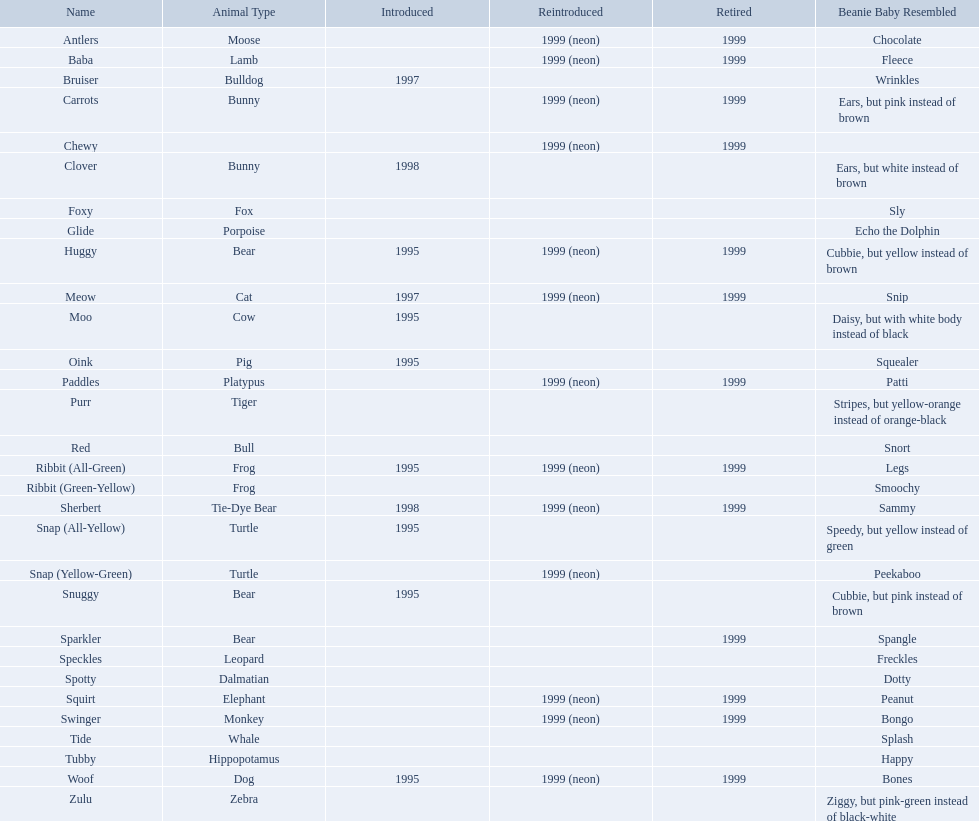What are all the different names of the pillow pals? Antlers, Baba, Bruiser, Carrots, Chewy, Clover, Foxy, Glide, Huggy, Meow, Moo, Oink, Paddles, Purr, Red, Ribbit (All-Green), Ribbit (Green-Yellow), Sherbert, Snap (All-Yellow), Snap (Yellow-Green), Snuggy, Sparkler, Speckles, Spotty, Squirt, Swinger, Tide, Tubby, Woof, Zulu. Which of these are a dalmatian? Spotty. What are the names listed? Antlers, Baba, Bruiser, Carrots, Chewy, Clover, Foxy, Glide, Huggy, Meow, Moo, Oink, Paddles, Purr, Red, Ribbit (All-Green), Ribbit (Green-Yellow), Sherbert, Snap (All-Yellow), Snap (Yellow-Green), Snuggy, Sparkler, Speckles, Spotty, Squirt, Swinger, Tide, Tubby, Woof, Zulu. Of these, which is the only pet without an animal type listed? Chewy. What are all the pillow pals? Antlers, Baba, Bruiser, Carrots, Chewy, Clover, Foxy, Glide, Huggy, Meow, Moo, Oink, Paddles, Purr, Red, Ribbit (All-Green), Ribbit (Green-Yellow), Sherbert, Snap (All-Yellow), Snap (Yellow-Green), Snuggy, Sparkler, Speckles, Spotty, Squirt, Swinger, Tide, Tubby, Woof, Zulu. Which is the only without a listed animal type? Chewy. What are the outlined names? Antlers, Baba, Bruiser, Carrots, Chewy, Clover, Foxy, Glide, Huggy, Meow, Moo, Oink, Paddles, Purr, Red, Ribbit (All-Green), Ribbit (Green-Yellow), Sherbert, Snap (All-Yellow), Snap (Yellow-Green), Snuggy, Sparkler, Speckles, Spotty, Squirt, Swinger, Tide, Tubby, Woof, Zulu. Could you parse the entire table as a dict? {'header': ['Name', 'Animal Type', 'Introduced', 'Reintroduced', 'Retired', 'Beanie Baby Resembled'], 'rows': [['Antlers', 'Moose', '', '1999 (neon)', '1999', 'Chocolate'], ['Baba', 'Lamb', '', '1999 (neon)', '1999', 'Fleece'], ['Bruiser', 'Bulldog', '1997', '', '', 'Wrinkles'], ['Carrots', 'Bunny', '', '1999 (neon)', '1999', 'Ears, but pink instead of brown'], ['Chewy', '', '', '1999 (neon)', '1999', ''], ['Clover', 'Bunny', '1998', '', '', 'Ears, but white instead of brown'], ['Foxy', 'Fox', '', '', '', 'Sly'], ['Glide', 'Porpoise', '', '', '', 'Echo the Dolphin'], ['Huggy', 'Bear', '1995', '1999 (neon)', '1999', 'Cubbie, but yellow instead of brown'], ['Meow', 'Cat', '1997', '1999 (neon)', '1999', 'Snip'], ['Moo', 'Cow', '1995', '', '', 'Daisy, but with white body instead of black'], ['Oink', 'Pig', '1995', '', '', 'Squealer'], ['Paddles', 'Platypus', '', '1999 (neon)', '1999', 'Patti'], ['Purr', 'Tiger', '', '', '', 'Stripes, but yellow-orange instead of orange-black'], ['Red', 'Bull', '', '', '', 'Snort'], ['Ribbit (All-Green)', 'Frog', '1995', '1999 (neon)', '1999', 'Legs'], ['Ribbit (Green-Yellow)', 'Frog', '', '', '', 'Smoochy'], ['Sherbert', 'Tie-Dye Bear', '1998', '1999 (neon)', '1999', 'Sammy'], ['Snap (All-Yellow)', 'Turtle', '1995', '', '', 'Speedy, but yellow instead of green'], ['Snap (Yellow-Green)', 'Turtle', '', '1999 (neon)', '', 'Peekaboo'], ['Snuggy', 'Bear', '1995', '', '', 'Cubbie, but pink instead of brown'], ['Sparkler', 'Bear', '', '', '1999', 'Spangle'], ['Speckles', 'Leopard', '', '', '', 'Freckles'], ['Spotty', 'Dalmatian', '', '', '', 'Dotty'], ['Squirt', 'Elephant', '', '1999 (neon)', '1999', 'Peanut'], ['Swinger', 'Monkey', '', '1999 (neon)', '1999', 'Bongo'], ['Tide', 'Whale', '', '', '', 'Splash'], ['Tubby', 'Hippopotamus', '', '', '', 'Happy'], ['Woof', 'Dog', '1995', '1999 (neon)', '1999', 'Bones'], ['Zulu', 'Zebra', '', '', '', 'Ziggy, but pink-green instead of black-white']]} From these, which is the only pet without a designated animal classification? Chewy. Would you be able to parse every entry in this table? {'header': ['Name', 'Animal Type', 'Introduced', 'Reintroduced', 'Retired', 'Beanie Baby Resembled'], 'rows': [['Antlers', 'Moose', '', '1999 (neon)', '1999', 'Chocolate'], ['Baba', 'Lamb', '', '1999 (neon)', '1999', 'Fleece'], ['Bruiser', 'Bulldog', '1997', '', '', 'Wrinkles'], ['Carrots', 'Bunny', '', '1999 (neon)', '1999', 'Ears, but pink instead of brown'], ['Chewy', '', '', '1999 (neon)', '1999', ''], ['Clover', 'Bunny', '1998', '', '', 'Ears, but white instead of brown'], ['Foxy', 'Fox', '', '', '', 'Sly'], ['Glide', 'Porpoise', '', '', '', 'Echo the Dolphin'], ['Huggy', 'Bear', '1995', '1999 (neon)', '1999', 'Cubbie, but yellow instead of brown'], ['Meow', 'Cat', '1997', '1999 (neon)', '1999', 'Snip'], ['Moo', 'Cow', '1995', '', '', 'Daisy, but with white body instead of black'], ['Oink', 'Pig', '1995', '', '', 'Squealer'], ['Paddles', 'Platypus', '', '1999 (neon)', '1999', 'Patti'], ['Purr', 'Tiger', '', '', '', 'Stripes, but yellow-orange instead of orange-black'], ['Red', 'Bull', '', '', '', 'Snort'], ['Ribbit (All-Green)', 'Frog', '1995', '1999 (neon)', '1999', 'Legs'], ['Ribbit (Green-Yellow)', 'Frog', '', '', '', 'Smoochy'], ['Sherbert', 'Tie-Dye Bear', '1998', '1999 (neon)', '1999', 'Sammy'], ['Snap (All-Yellow)', 'Turtle', '1995', '', '', 'Speedy, but yellow instead of green'], ['Snap (Yellow-Green)', 'Turtle', '', '1999 (neon)', '', 'Peekaboo'], ['Snuggy', 'Bear', '1995', '', '', 'Cubbie, but pink instead of brown'], ['Sparkler', 'Bear', '', '', '1999', 'Spangle'], ['Speckles', 'Leopard', '', '', '', 'Freckles'], ['Spotty', 'Dalmatian', '', '', '', 'Dotty'], ['Squirt', 'Elephant', '', '1999 (neon)', '1999', 'Peanut'], ['Swinger', 'Monkey', '', '1999 (neon)', '1999', 'Bongo'], ['Tide', 'Whale', '', '', '', 'Splash'], ['Tubby', 'Hippopotamus', '', '', '', 'Happy'], ['Woof', 'Dog', '1995', '1999 (neon)', '1999', 'Bones'], ['Zulu', 'Zebra', '', '', '', 'Ziggy, but pink-green instead of black-white']]} What animals are cushion buddies? Moose, Lamb, Bulldog, Bunny, Bunny, Fox, Porpoise, Bear, Cat, Cow, Pig, Platypus, Tiger, Bull, Frog, Frog, Tie-Dye Bear, Turtle, Turtle, Bear, Bear, Leopard, Dalmatian, Elephant, Monkey, Whale, Hippopotamus, Dog, Zebra. What is the name of the dalmatian? Spotty. What are all the alternative names for pillow pals? Antlers, Baba, Bruiser, Carrots, Chewy, Clover, Foxy, Glide, Huggy, Meow, Moo, Oink, Paddles, Purr, Red, Ribbit (All-Green), Ribbit (Green-Yellow), Sherbert, Snap (All-Yellow), Snap (Yellow-Green), Snuggy, Sparkler, Speckles, Spotty, Squirt, Swinger, Tide, Tubby, Woof, Zulu. Which of them represent a dalmatian? Spotty. What are the enumerated names? Antlers, Baba, Bruiser, Carrots, Chewy, Clover, Foxy, Glide, Huggy, Meow, Moo, Oink, Paddles, Purr, Red, Ribbit (All-Green), Ribbit (Green-Yellow), Sherbert, Snap (All-Yellow), Snap (Yellow-Green), Snuggy, Sparkler, Speckles, Spotty, Squirt, Swinger, Tide, Tubby, Woof, Zulu. Of these, which is the sole pet without an indicated animal kind? Chewy. What are all the cushion companions? Antlers, Baba, Bruiser, Carrots, Chewy, Clover, Foxy, Glide, Huggy, Meow, Moo, Oink, Paddles, Purr, Red, Ribbit (All-Green), Ribbit (Green-Yellow), Sherbert, Snap (All-Yellow), Snap (Yellow-Green), Snuggy, Sparkler, Speckles, Spotty, Squirt, Swinger, Tide, Tubby, Woof, Zulu. Which is the only one without a specified animal kind? Chewy. Give me the full table as a dictionary. {'header': ['Name', 'Animal Type', 'Introduced', 'Reintroduced', 'Retired', 'Beanie Baby Resembled'], 'rows': [['Antlers', 'Moose', '', '1999 (neon)', '1999', 'Chocolate'], ['Baba', 'Lamb', '', '1999 (neon)', '1999', 'Fleece'], ['Bruiser', 'Bulldog', '1997', '', '', 'Wrinkles'], ['Carrots', 'Bunny', '', '1999 (neon)', '1999', 'Ears, but pink instead of brown'], ['Chewy', '', '', '1999 (neon)', '1999', ''], ['Clover', 'Bunny', '1998', '', '', 'Ears, but white instead of brown'], ['Foxy', 'Fox', '', '', '', 'Sly'], ['Glide', 'Porpoise', '', '', '', 'Echo the Dolphin'], ['Huggy', 'Bear', '1995', '1999 (neon)', '1999', 'Cubbie, but yellow instead of brown'], ['Meow', 'Cat', '1997', '1999 (neon)', '1999', 'Snip'], ['Moo', 'Cow', '1995', '', '', 'Daisy, but with white body instead of black'], ['Oink', 'Pig', '1995', '', '', 'Squealer'], ['Paddles', 'Platypus', '', '1999 (neon)', '1999', 'Patti'], ['Purr', 'Tiger', '', '', '', 'Stripes, but yellow-orange instead of orange-black'], ['Red', 'Bull', '', '', '', 'Snort'], ['Ribbit (All-Green)', 'Frog', '1995', '1999 (neon)', '1999', 'Legs'], ['Ribbit (Green-Yellow)', 'Frog', '', '', '', 'Smoochy'], ['Sherbert', 'Tie-Dye Bear', '1998', '1999 (neon)', '1999', 'Sammy'], ['Snap (All-Yellow)', 'Turtle', '1995', '', '', 'Speedy, but yellow instead of green'], ['Snap (Yellow-Green)', 'Turtle', '', '1999 (neon)', '', 'Peekaboo'], ['Snuggy', 'Bear', '1995', '', '', 'Cubbie, but pink instead of brown'], ['Sparkler', 'Bear', '', '', '1999', 'Spangle'], ['Speckles', 'Leopard', '', '', '', 'Freckles'], ['Spotty', 'Dalmatian', '', '', '', 'Dotty'], ['Squirt', 'Elephant', '', '1999 (neon)', '1999', 'Peanut'], ['Swinger', 'Monkey', '', '1999 (neon)', '1999', 'Bongo'], ['Tide', 'Whale', '', '', '', 'Splash'], ['Tubby', 'Hippopotamus', '', '', '', 'Happy'], ['Woof', 'Dog', '1995', '1999 (neon)', '1999', 'Bones'], ['Zulu', 'Zebra', '', '', '', 'Ziggy, but pink-green instead of black-white']]} What are the various names given to pillow pals? Antlers, Baba, Bruiser, Carrots, Chewy, Clover, Foxy, Glide, Huggy, Meow, Moo, Oink, Paddles, Purr, Red, Ribbit (All-Green), Ribbit (Green-Yellow), Sherbert, Snap (All-Yellow), Snap (Yellow-Green), Snuggy, Sparkler, Speckles, Spotty, Squirt, Swinger, Tide, Tubby, Woof, Zulu. Can you identify the dalmatian ones? Spotty. What kind of animals are classified as pillow pals? Moose, Lamb, Bulldog, Bunny, Bunny, Fox, Porpoise, Bear, Cat, Cow, Pig, Platypus, Tiger, Bull, Frog, Frog, Tie-Dye Bear, Turtle, Turtle, Bear, Bear, Leopard, Dalmatian, Elephant, Monkey, Whale, Hippopotamus, Dog, Zebra. What is the appellation of the dalmatian? Spotty. 